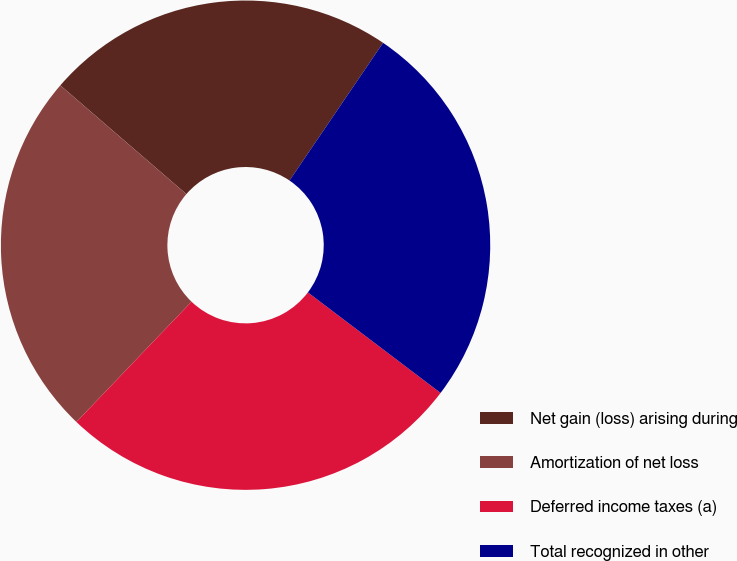Convert chart to OTSL. <chart><loc_0><loc_0><loc_500><loc_500><pie_chart><fcel>Net gain (loss) arising during<fcel>Amortization of net loss<fcel>Deferred income taxes (a)<fcel>Total recognized in other<nl><fcel>23.17%<fcel>24.18%<fcel>26.83%<fcel>25.82%<nl></chart> 